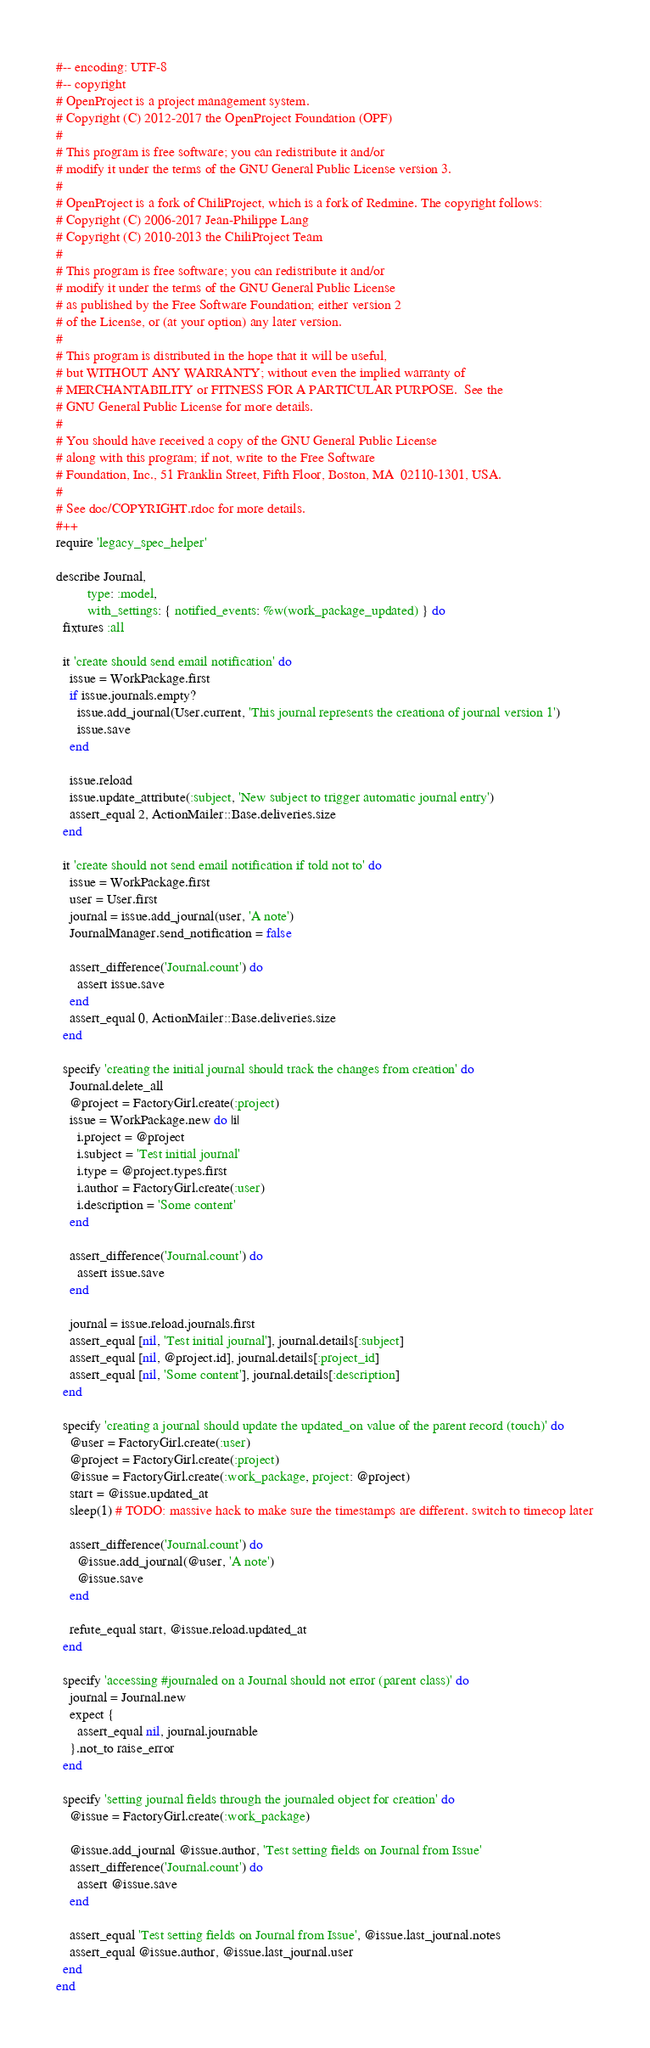Convert code to text. <code><loc_0><loc_0><loc_500><loc_500><_Ruby_>#-- encoding: UTF-8
#-- copyright
# OpenProject is a project management system.
# Copyright (C) 2012-2017 the OpenProject Foundation (OPF)
#
# This program is free software; you can redistribute it and/or
# modify it under the terms of the GNU General Public License version 3.
#
# OpenProject is a fork of ChiliProject, which is a fork of Redmine. The copyright follows:
# Copyright (C) 2006-2017 Jean-Philippe Lang
# Copyright (C) 2010-2013 the ChiliProject Team
#
# This program is free software; you can redistribute it and/or
# modify it under the terms of the GNU General Public License
# as published by the Free Software Foundation; either version 2
# of the License, or (at your option) any later version.
#
# This program is distributed in the hope that it will be useful,
# but WITHOUT ANY WARRANTY; without even the implied warranty of
# MERCHANTABILITY or FITNESS FOR A PARTICULAR PURPOSE.  See the
# GNU General Public License for more details.
#
# You should have received a copy of the GNU General Public License
# along with this program; if not, write to the Free Software
# Foundation, Inc., 51 Franklin Street, Fifth Floor, Boston, MA  02110-1301, USA.
#
# See doc/COPYRIGHT.rdoc for more details.
#++
require 'legacy_spec_helper'

describe Journal,
         type: :model,
         with_settings: { notified_events: %w(work_package_updated) } do
  fixtures :all

  it 'create should send email notification' do
    issue = WorkPackage.first
    if issue.journals.empty?
      issue.add_journal(User.current, 'This journal represents the creationa of journal version 1')
      issue.save
    end

    issue.reload
    issue.update_attribute(:subject, 'New subject to trigger automatic journal entry')
    assert_equal 2, ActionMailer::Base.deliveries.size
  end

  it 'create should not send email notification if told not to' do
    issue = WorkPackage.first
    user = User.first
    journal = issue.add_journal(user, 'A note')
    JournalManager.send_notification = false

    assert_difference('Journal.count') do
      assert issue.save
    end
    assert_equal 0, ActionMailer::Base.deliveries.size
  end

  specify 'creating the initial journal should track the changes from creation' do
    Journal.delete_all
    @project = FactoryGirl.create(:project)
    issue = WorkPackage.new do |i|
      i.project = @project
      i.subject = 'Test initial journal'
      i.type = @project.types.first
      i.author = FactoryGirl.create(:user)
      i.description = 'Some content'
    end

    assert_difference('Journal.count') do
      assert issue.save
    end

    journal = issue.reload.journals.first
    assert_equal [nil, 'Test initial journal'], journal.details[:subject]
    assert_equal [nil, @project.id], journal.details[:project_id]
    assert_equal [nil, 'Some content'], journal.details[:description]
  end

  specify 'creating a journal should update the updated_on value of the parent record (touch)' do
    @user = FactoryGirl.create(:user)
    @project = FactoryGirl.create(:project)
    @issue = FactoryGirl.create(:work_package, project: @project)
    start = @issue.updated_at
    sleep(1) # TODO: massive hack to make sure the timestamps are different. switch to timecop later

    assert_difference('Journal.count') do
      @issue.add_journal(@user, 'A note')
      @issue.save
    end

    refute_equal start, @issue.reload.updated_at
  end

  specify 'accessing #journaled on a Journal should not error (parent class)' do
    journal = Journal.new
    expect {
      assert_equal nil, journal.journable
    }.not_to raise_error
  end

  specify 'setting journal fields through the journaled object for creation' do
    @issue = FactoryGirl.create(:work_package)

    @issue.add_journal @issue.author, 'Test setting fields on Journal from Issue'
    assert_difference('Journal.count') do
      assert @issue.save
    end

    assert_equal 'Test setting fields on Journal from Issue', @issue.last_journal.notes
    assert_equal @issue.author, @issue.last_journal.user
  end
end
</code> 